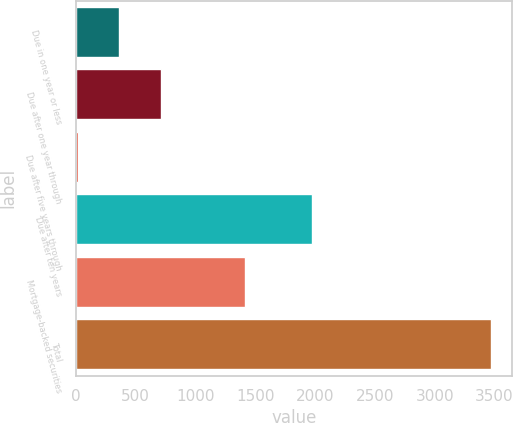Convert chart to OTSL. <chart><loc_0><loc_0><loc_500><loc_500><bar_chart><fcel>Due in one year or less<fcel>Due after one year through<fcel>Due after five years through<fcel>Due after ten years<fcel>Mortgage-backed securities<fcel>Total<nl><fcel>363.1<fcel>708.2<fcel>18<fcel>1970<fcel>1418<fcel>3469<nl></chart> 